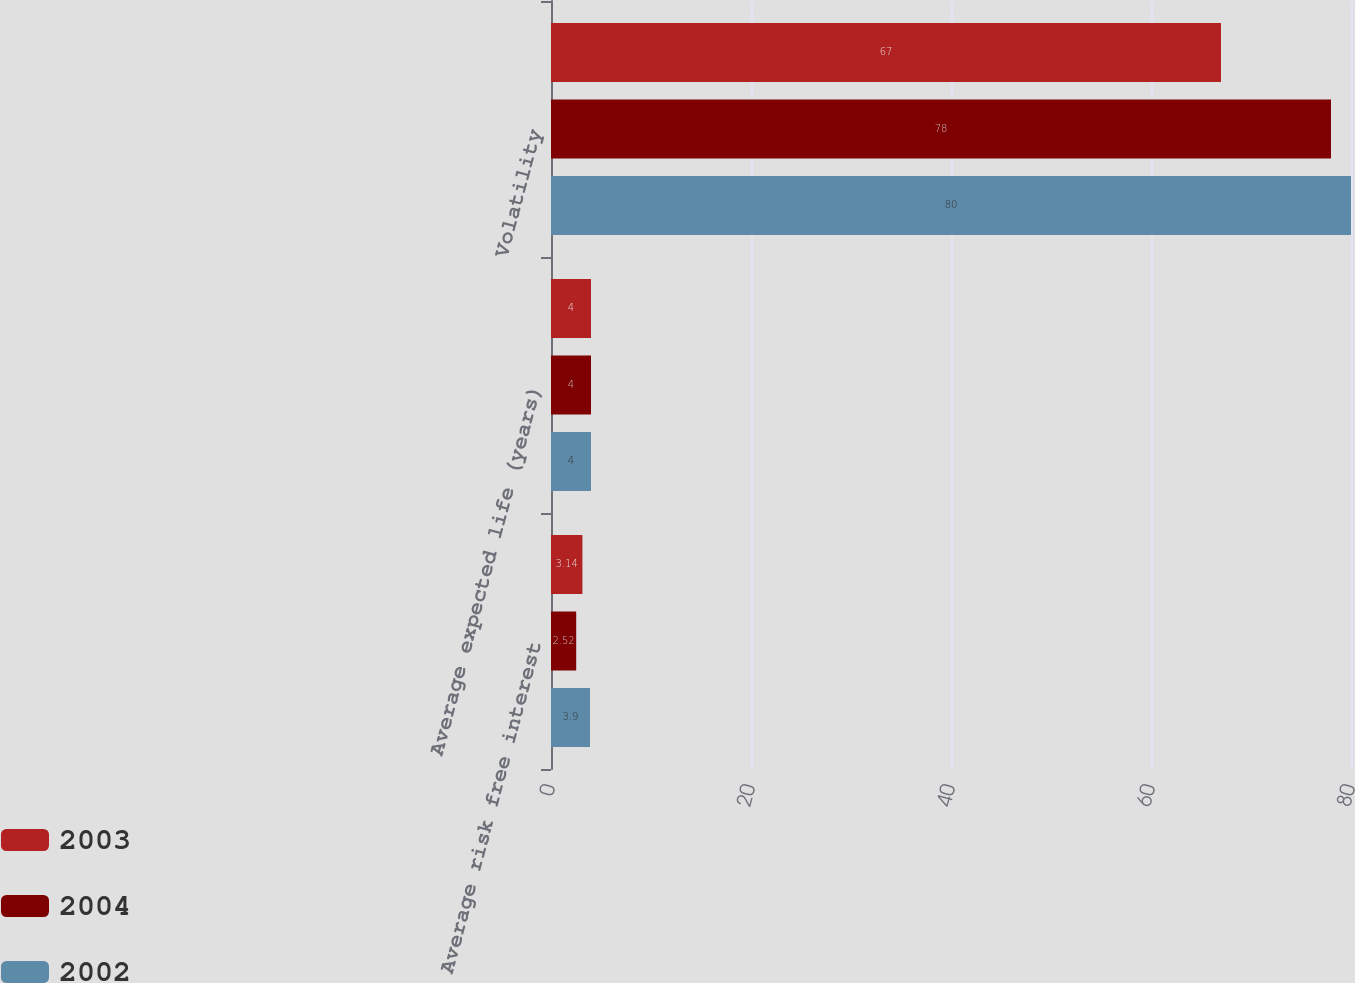<chart> <loc_0><loc_0><loc_500><loc_500><stacked_bar_chart><ecel><fcel>Average risk free interest<fcel>Average expected life (years)<fcel>Volatility<nl><fcel>2003<fcel>3.14<fcel>4<fcel>67<nl><fcel>2004<fcel>2.52<fcel>4<fcel>78<nl><fcel>2002<fcel>3.9<fcel>4<fcel>80<nl></chart> 